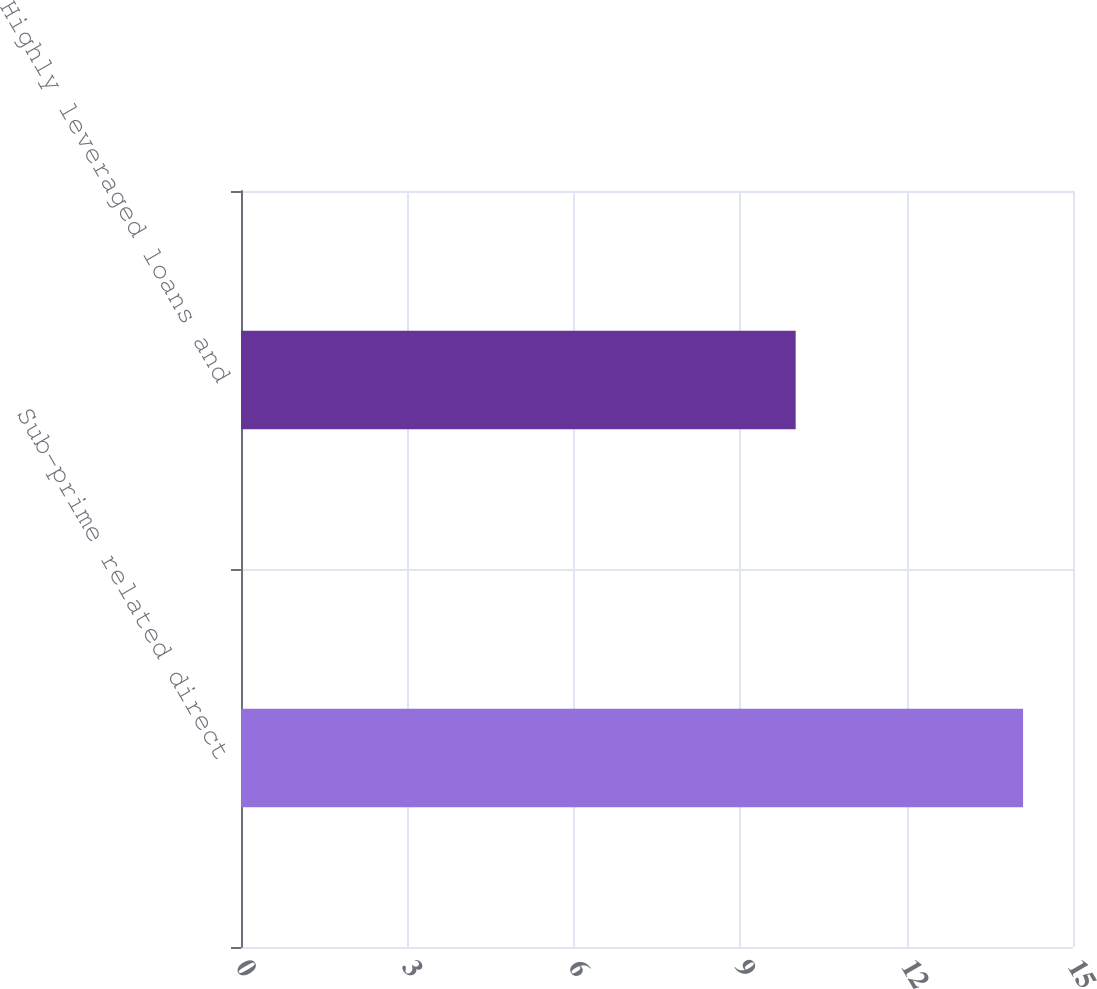Convert chart. <chart><loc_0><loc_0><loc_500><loc_500><bar_chart><fcel>Sub-prime related direct<fcel>Highly leveraged loans and<nl><fcel>14.1<fcel>10<nl></chart> 